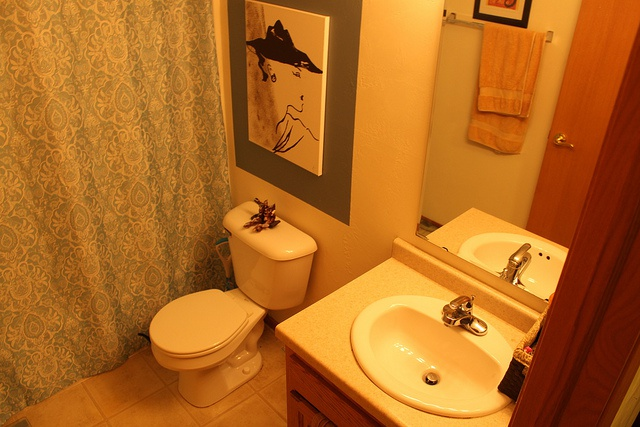Describe the objects in this image and their specific colors. I can see sink in orange and gold tones and toilet in orange and red tones in this image. 